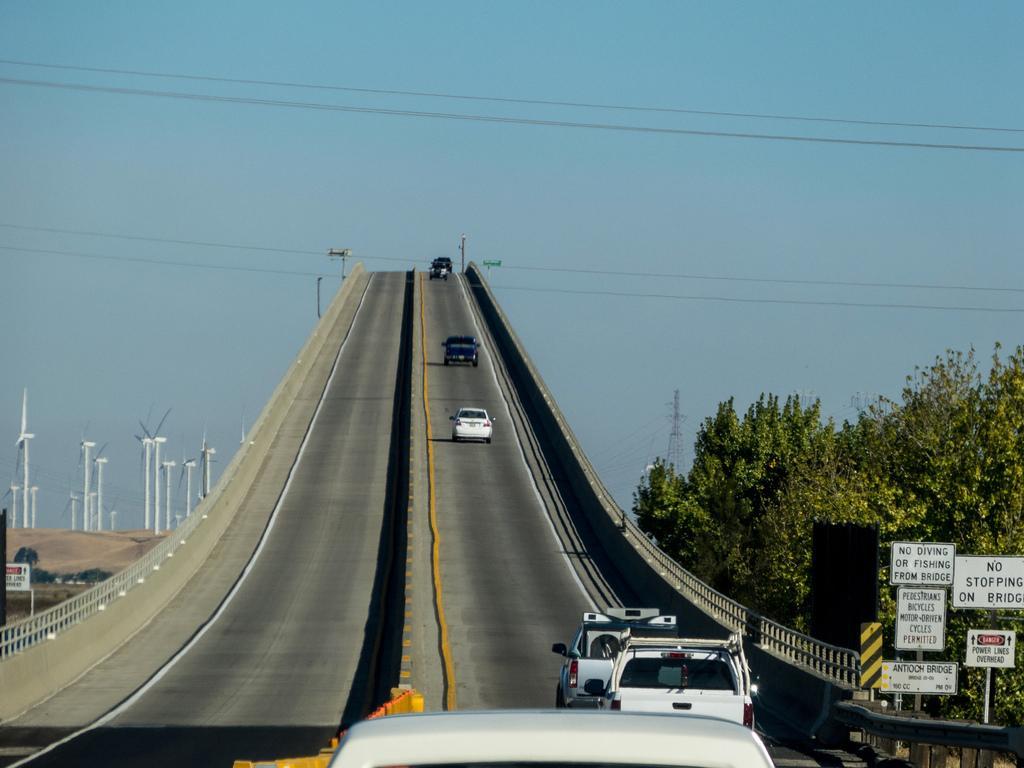Could you give a brief overview of what you see in this image? In this picture, we see a bridge. On either side of the bridge, we see the railing. At the bottom, we see the cars moving on the road. In the middle, we see the vehicles are moving on the road. On the right side, we see the trees, poles, power transformer and the boards in white color with some text written on it. In the left bottom, we see the trees and a board in white color with some text written on it. Behind that, we see the sand and the windmills. At the top, we see the sky. 